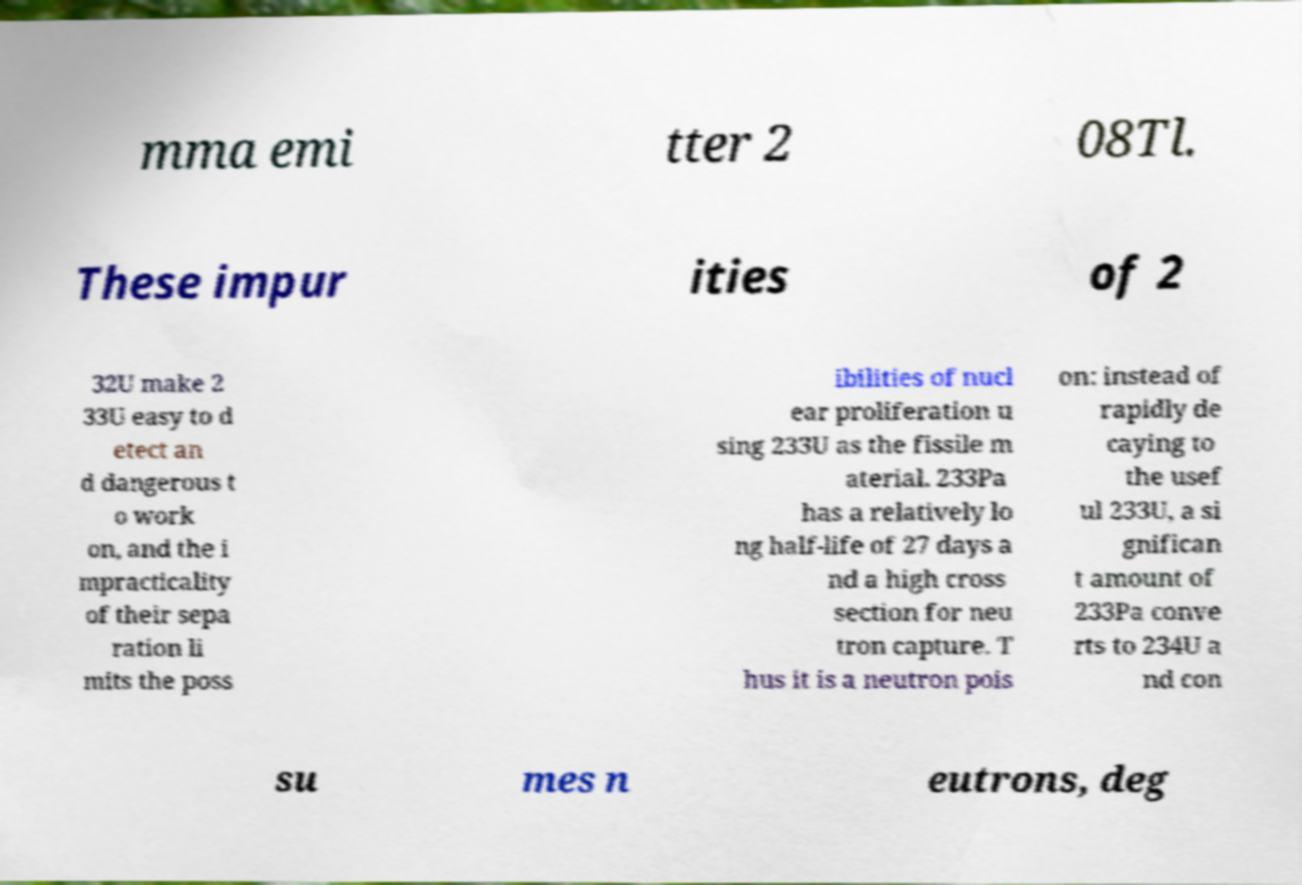Could you extract and type out the text from this image? mma emi tter 2 08Tl. These impur ities of 2 32U make 2 33U easy to d etect an d dangerous t o work on, and the i mpracticality of their sepa ration li mits the poss ibilities of nucl ear proliferation u sing 233U as the fissile m aterial. 233Pa has a relatively lo ng half-life of 27 days a nd a high cross section for neu tron capture. T hus it is a neutron pois on: instead of rapidly de caying to the usef ul 233U, a si gnifican t amount of 233Pa conve rts to 234U a nd con su mes n eutrons, deg 